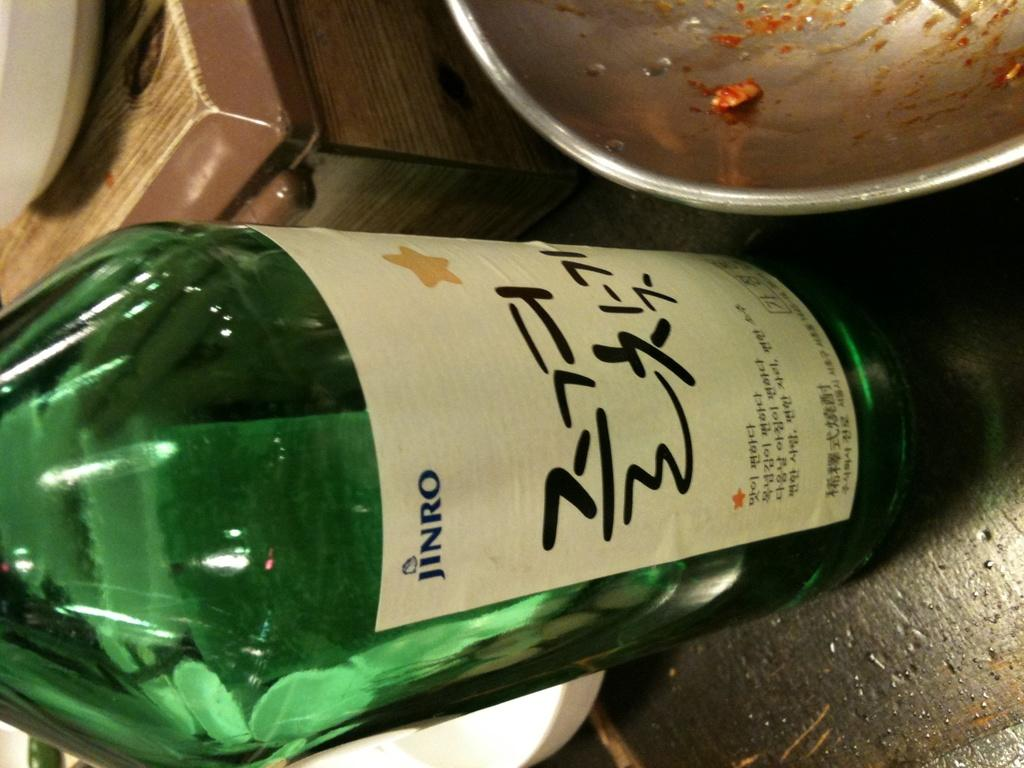<image>
Describe the image concisely. A green bottle on a table with the brand Jinro. 